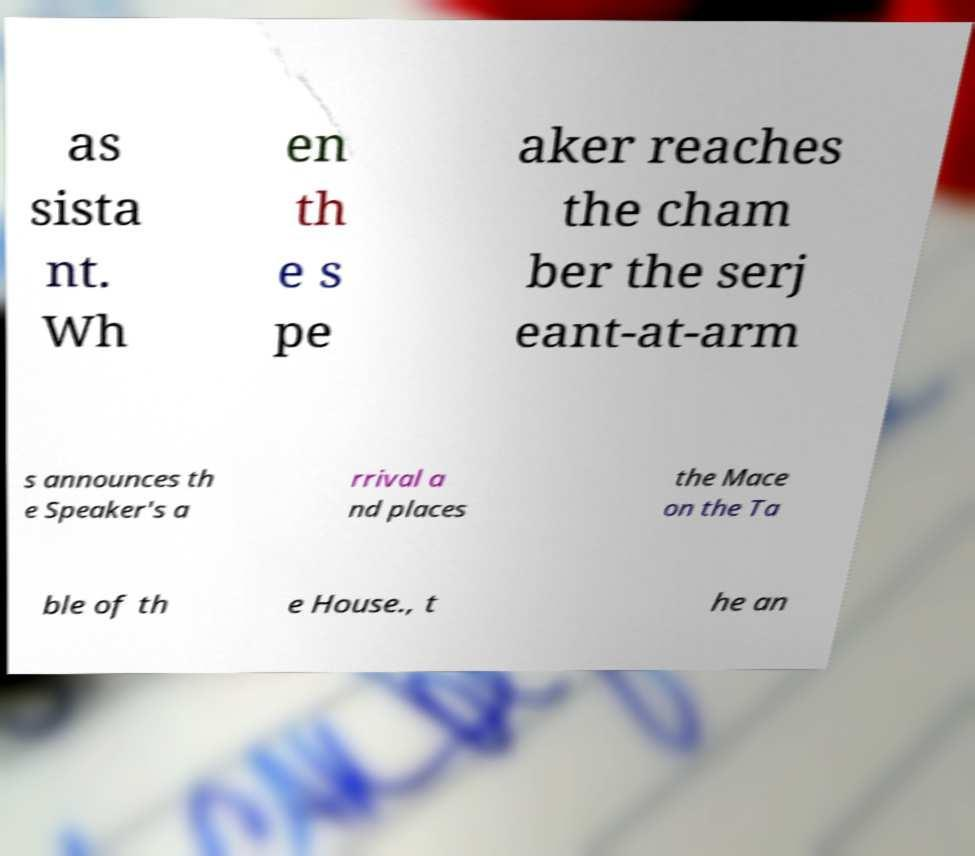I need the written content from this picture converted into text. Can you do that? as sista nt. Wh en th e s pe aker reaches the cham ber the serj eant-at-arm s announces th e Speaker's a rrival a nd places the Mace on the Ta ble of th e House., t he an 